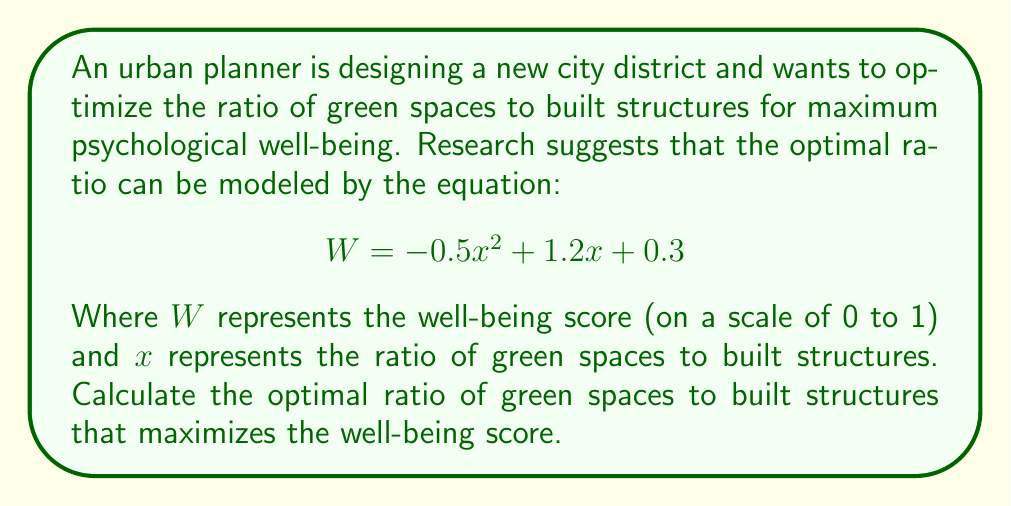Give your solution to this math problem. To find the optimal ratio, we need to find the maximum value of the quadratic function $W = -0.5x^2 + 1.2x + 0.3$. This occurs at the vertex of the parabola.

Step 1: For a quadratic function in the form $f(x) = ax^2 + bx + c$, the x-coordinate of the vertex is given by $x = -\frac{b}{2a}$.

Step 2: In our equation, $a = -0.5$ and $b = 1.2$. Let's substitute these values:

$$x = -\frac{1.2}{2(-0.5)} = -\frac{1.2}{-1} = 1.2$$

Step 3: To verify this is a maximum (not a minimum), we can check that $a < 0$, which is true in this case ($a = -0.5$).

Therefore, the optimal ratio of green spaces to built structures is 1.2 to 1, or 1.2:1.
Answer: 1.2:1 